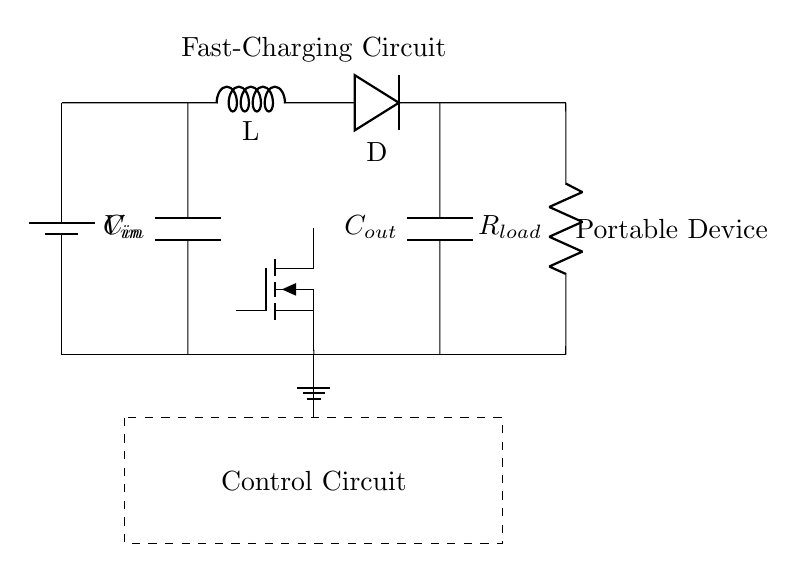What does the battery represent in this circuit? The battery represents the power source, supplying voltage to the circuit components.
Answer: power source What type of device is being charged with this circuit? The circuit diagram indicates that it is intended for a portable device, typically used in mobile electronics.
Answer: portable device What is the function of the inductor in this circuit? The inductor is used to store energy temporarily and smooth out the current flow, contributing to the charging process.
Answer: energy storage How many capacitors are present in the circuit? There are two capacitors shown in the circuit diagram, one at the input and one at the output.
Answer: two What role does the control circuit play in this fast-charging design? The control circuit regulates the charging process by managing the MOSFET operation, ensuring safe and efficient charging.
Answer: regulates charging What is the output load of this circuit labeled as? The output load is labeled as R_load, representing the resistance of the device being charged.
Answer: R_load 